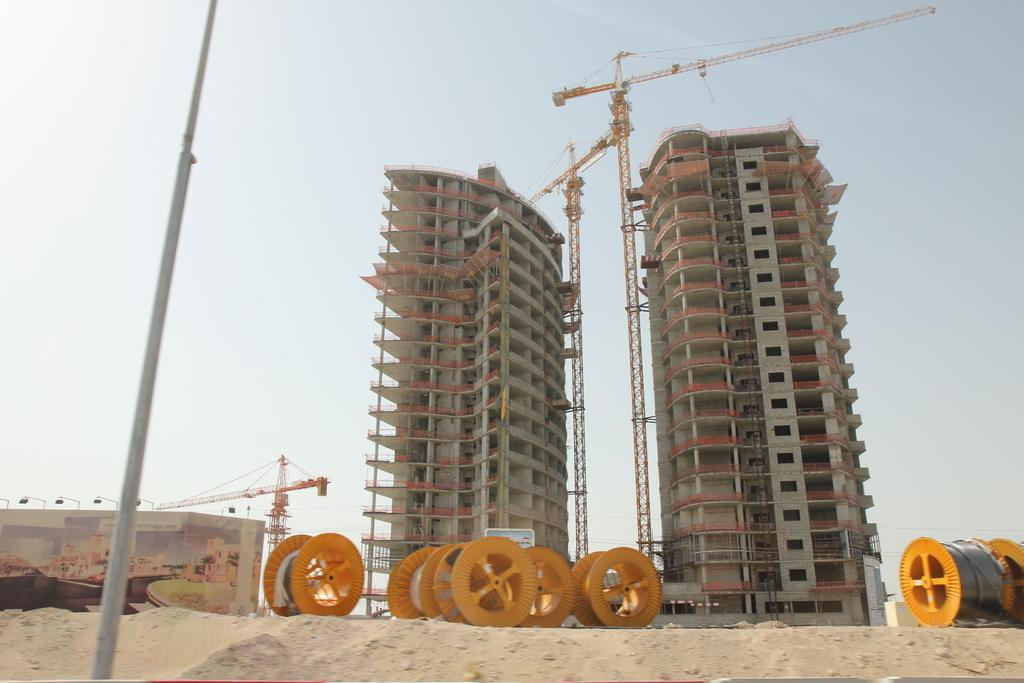What objects are on the ground in the image? There are yellow color wheels on the ground. What can be seen to the left of the image? There is a pole to the left of the image. What structures are visible in the background of the image? There are two buildings in the background of the image. What is visible in the sky in the image? The sky is visible in the background of the image. How many spiders are crawling on the color wheels in the image? There are no spiders present in the image; it only features yellow color wheels on the ground. What are the hands doing in the image? There are no hands visible in the image. 